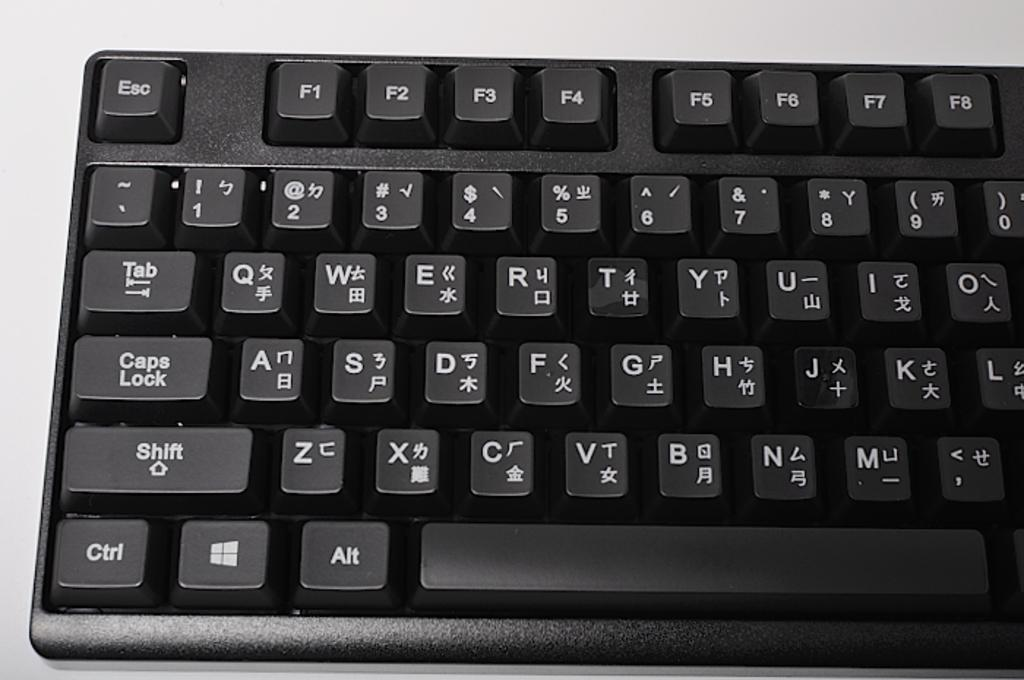<image>
Render a clear and concise summary of the photo. a close up of a black keyboard with keys for Caps Lock and Shift 